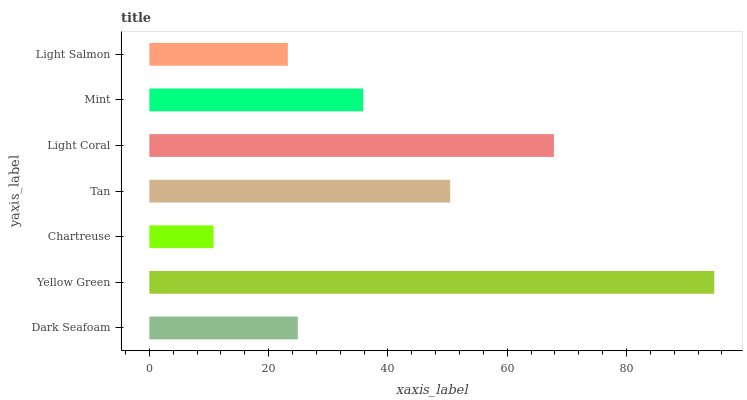Is Chartreuse the minimum?
Answer yes or no. Yes. Is Yellow Green the maximum?
Answer yes or no. Yes. Is Yellow Green the minimum?
Answer yes or no. No. Is Chartreuse the maximum?
Answer yes or no. No. Is Yellow Green greater than Chartreuse?
Answer yes or no. Yes. Is Chartreuse less than Yellow Green?
Answer yes or no. Yes. Is Chartreuse greater than Yellow Green?
Answer yes or no. No. Is Yellow Green less than Chartreuse?
Answer yes or no. No. Is Mint the high median?
Answer yes or no. Yes. Is Mint the low median?
Answer yes or no. Yes. Is Yellow Green the high median?
Answer yes or no. No. Is Light Salmon the low median?
Answer yes or no. No. 